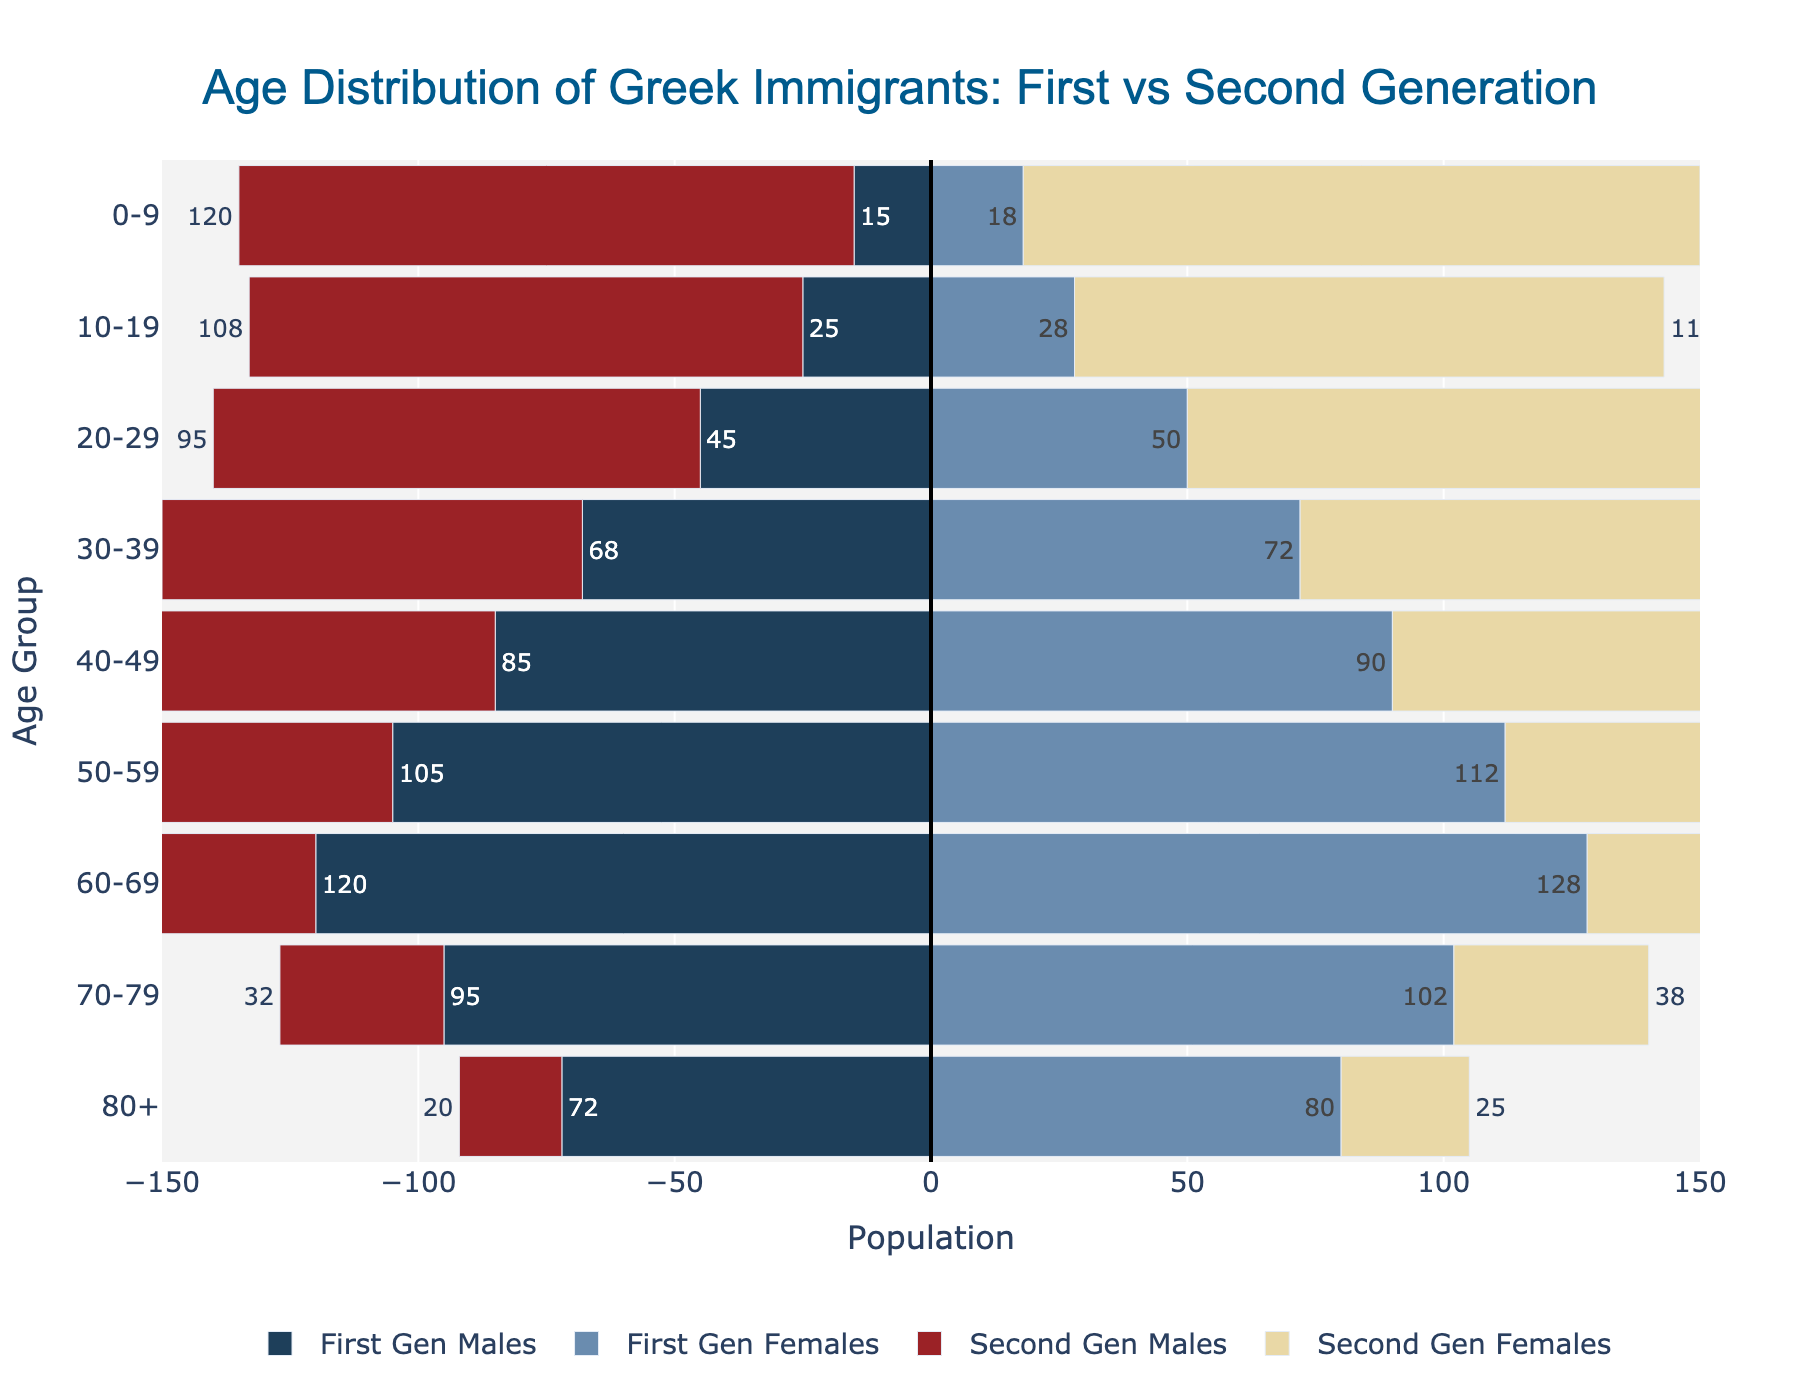What is the title of the population pyramid? The title is written at the top of the figure in a larger font. It reads "Age Distribution of Greek Immigrants: First vs Second Generation".
Answer: Age Distribution of Greek Immigrants: First vs Second Generation What age group has the highest number of first-generation males? Look for the bar that extends the farthest to the left on the horizontal axis that represents first-generation males. The longest bar representing first-generation males falls under the 60-69 age group.
Answer: 60-69 What is the total number of second-generation females in the 20-29 age group? The second-generation females' bar in the 20-29 age group is labeled with numbers showing the population. This number is 102.
Answer: 102 Which gender has a larger elderly (80+) population in the first generation? Compare the lengths or population values of the bars for first-generation males and first-generation females in the 80+ age group. The label for first-generation females (80) is greater than that for first-generation males (72).
Answer: Females How does the population of second-generation males and females compare in the 0-9 age group? For the 0-9 age group, compare the length and labels of the bars for second-generation males and females. The number of second-generation males is 120, and for females, it is 132.
Answer: Females are more What is the difference in the population of first-generation and second-generation males in the 50-59 age group? Find the labels for both first and second-generation males in the 50-59 age group and subtract the second-generation males from the first-generation males. The population of first-generation males is 105, and second-generation males is 58, so 105 - 58 = 47.
Answer: 47 Which age group has a more balanced gender distribution among first-generation Greeks? Identify the age group where the bars for first-generation males and first-generation females are closest in length, indicating a balanced distribution. The 40-49 age group has bars with very close numbers: 85 (males) and 90 (females).
Answer: 40-49 In which age group is the disparity between first and second-generation females the greatest? Calculate the disparity for each age group by subtracting the second-generation females from first-generation females. The highest difference is in the 60-69 age group, with 128 (first-gen females) - 50 (second-gen females) = 78.
Answer: 60-69 How does the population compare between first-generation males and females in the 30-39 age group? Compare the values for first-generation males (68) and first-generation females (72) in the 30-39 age group.
Answer: Females are more 